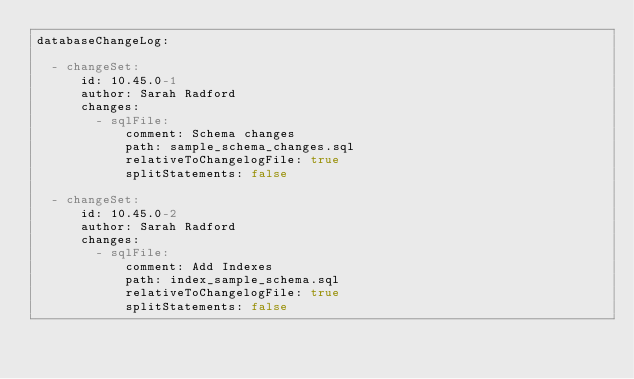Convert code to text. <code><loc_0><loc_0><loc_500><loc_500><_YAML_>databaseChangeLog:

  - changeSet:
      id: 10.45.0-1
      author: Sarah Radford
      changes:
        - sqlFile:
            comment: Schema changes
            path: sample_schema_changes.sql
            relativeToChangelogFile: true
            splitStatements: false

  - changeSet:
      id: 10.45.0-2
      author: Sarah Radford
      changes:
        - sqlFile:
            comment: Add Indexes
            path: index_sample_schema.sql
            relativeToChangelogFile: true
            splitStatements: false
</code> 